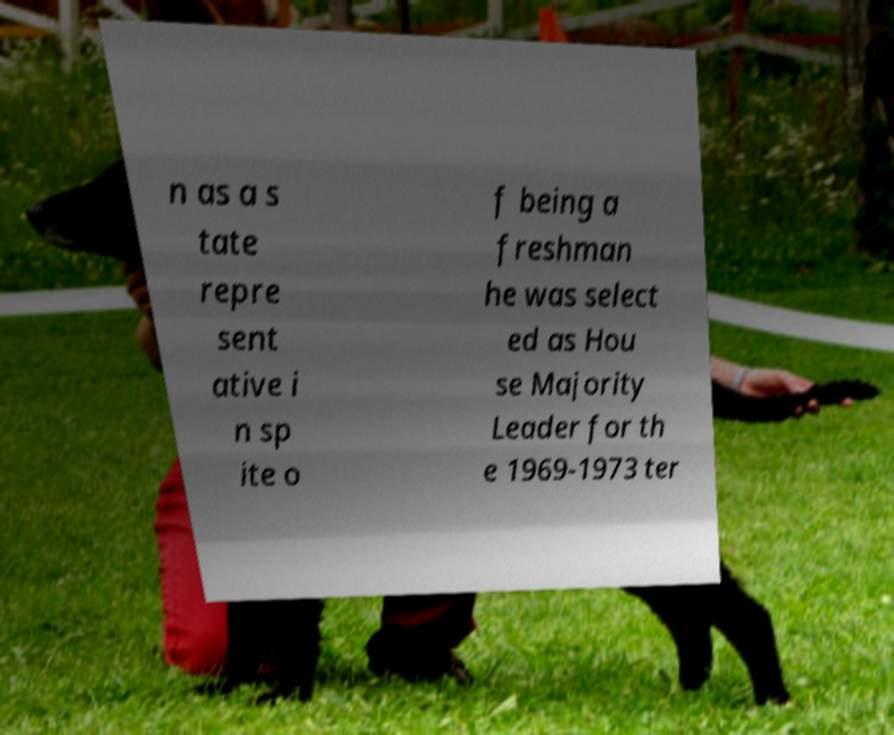Please identify and transcribe the text found in this image. n as a s tate repre sent ative i n sp ite o f being a freshman he was select ed as Hou se Majority Leader for th e 1969-1973 ter 